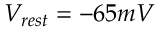Convert formula to latex. <formula><loc_0><loc_0><loc_500><loc_500>V _ { r e s t } = - 6 5 m V</formula> 